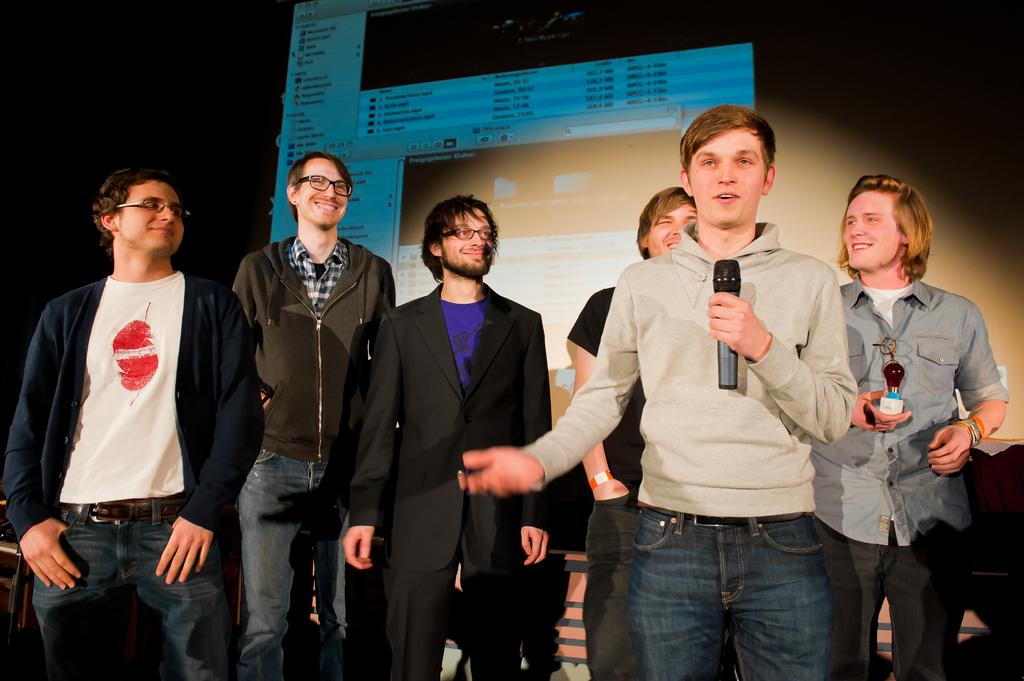How many people are visible in the image? There are people standing in the image. What is one person doing in the image? One person is holding a mic and talking. What can be seen on the screen in the background? There is a screen with a picture in the background. What type of leather is being used to make the heart visible in the image? There is no leather or heart present in the image. 